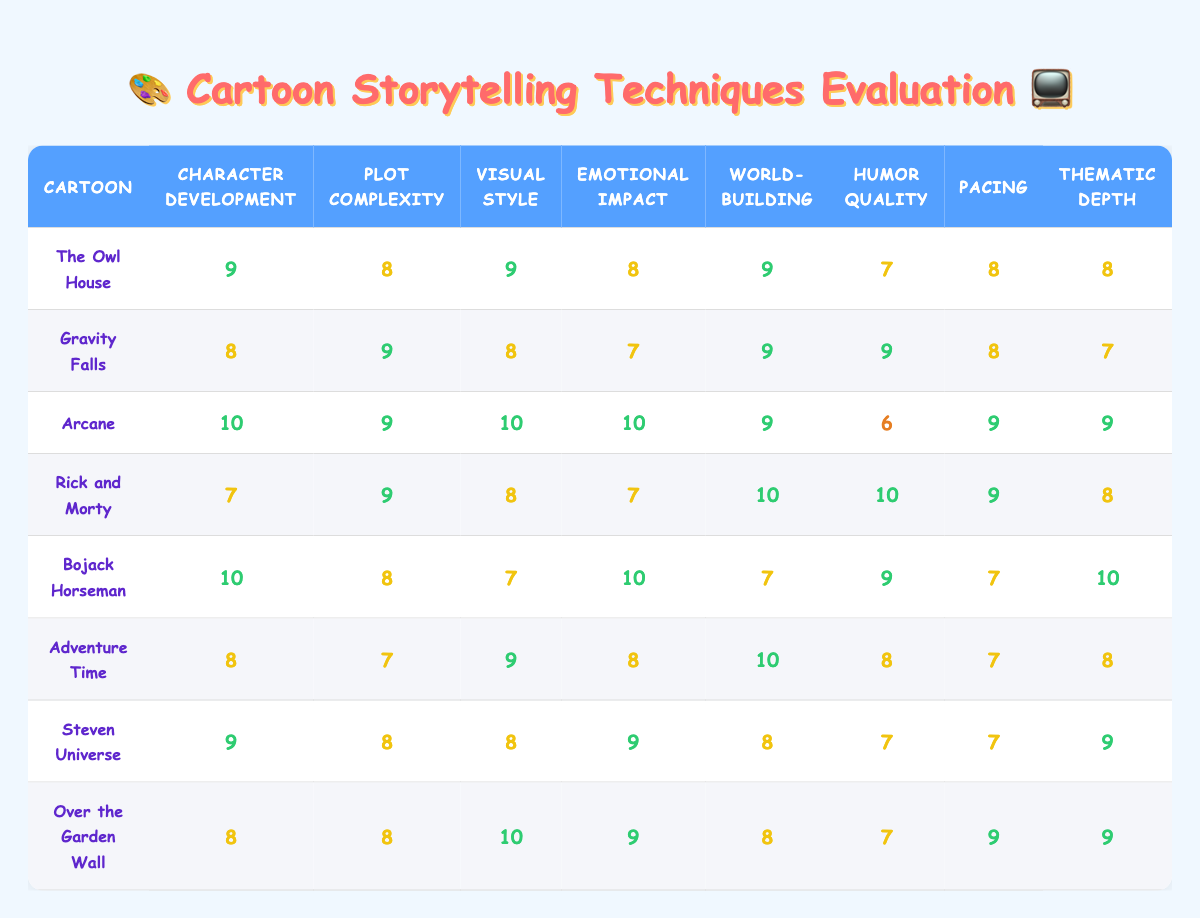What is the highest score for Character Development? The highest score for Character Development in the table is 10, which is awarded to both Arcane and Bojack Horseman.
Answer: 10 Which cartoon has the lowest score in Humor Quality? The lowest score in Humor Quality is 6, which is given to Arcane.
Answer: 6 What is the average score for Emotional Impact across all cartoons? To find the average, we sum the Emotional Impact scores: (8 + 7 + 10 + 7 + 10 + 8 + 9 + 9) = 68. There are 8 cartoons, so the average is 68/8 = 8.5.
Answer: 8.5 Does Gravity Falls have a higher score in Plot Complexity than Adventure Time? Gravity Falls has a score of 9 in Plot Complexity, while Adventure Time has a score of 7. Since 9 > 7, the statement is true.
Answer: Yes Which cartoon excels in both Visual Style and Emotional Impact? Arcane has the highest score (10) in Visual Style and also scores 10 in Emotional Impact, which indicates it excels in both categories.
Answer: Arcane What is the total score for World-building across all cartoons? By summing the World-building scores: (9 + 9 + 9 + 10 + 7 + 10 + 8 + 8) = 70.
Answer: 70 Which cartoon has the best overall score in Pacing? Rick and Morty has the best score in Pacing with a score of 9.
Answer: 9 Is the score for Thematic Depth in Steven Universe higher than that in Gravity Falls? Steven Universe scores 9 in Thematic Depth, while Gravity Falls scores 7. Thus, Steven Universe has a higher score.
Answer: Yes Which cartoon ranks second highest for overall scores, if we consider all the individual category scores? Arcane has scores: (10, 9, 10, 10, 9, 6, 9, 9) → total = 82. The cartoon with the second highest total is Bojack Horseman with a total score of 69.
Answer: Bojack Horseman 